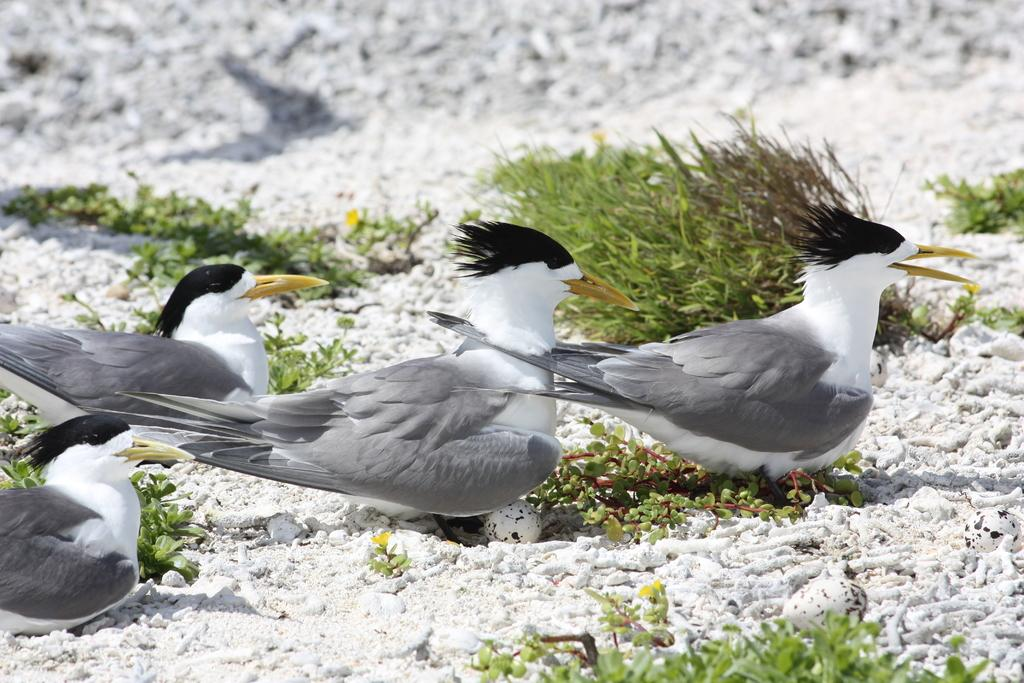What type of animals can be seen in the picture? Birds can be seen in the picture. What else is present in the picture besides the birds? There are plants and eggs in the picture. Where is the vase located in the picture? There is no vase present in the picture. What type of mailbox can be seen in the picture? There is no mailbox present in the picture. 